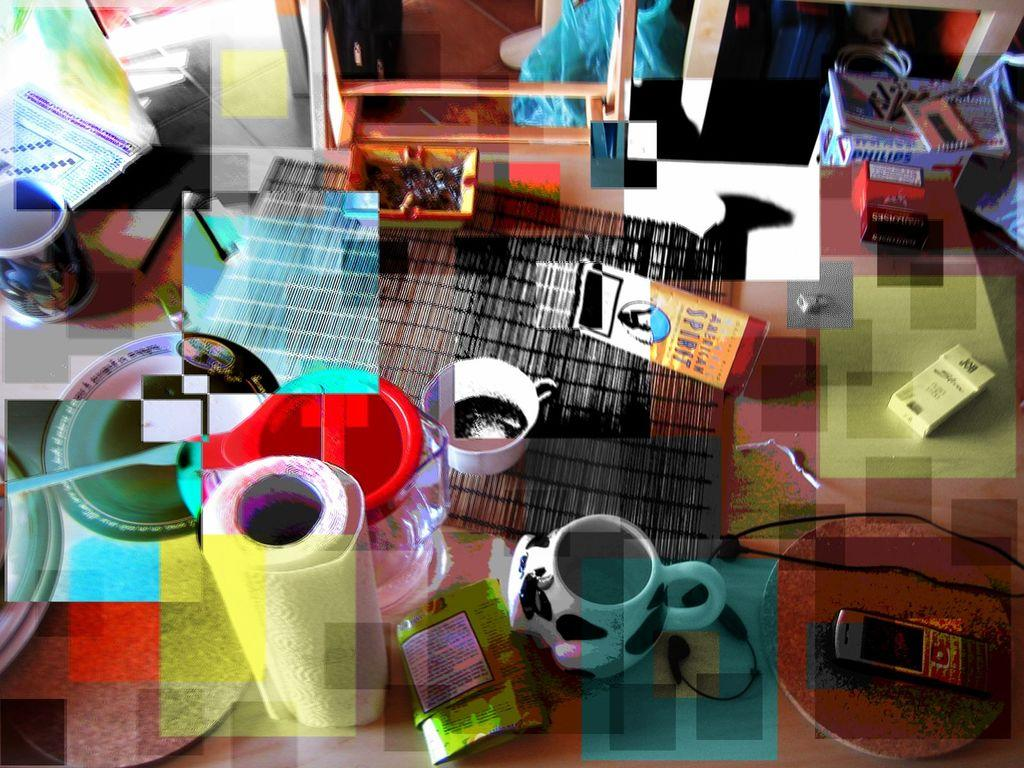What piece of furniture is present in the image? There is a table in the image. What items can be seen on the table? There are cups, stamps, a mobile phone, cigarette packets, and some products on the table. Can you describe the cups on the table? The cups are on the table, but their specific characteristics are not mentioned in the facts. What type of products are on the table? The specific type of products is not mentioned in the facts. What decision was made about the degree of the pear in the image? There is no pear present in the image, and therefore no decision about its degree can be made. 